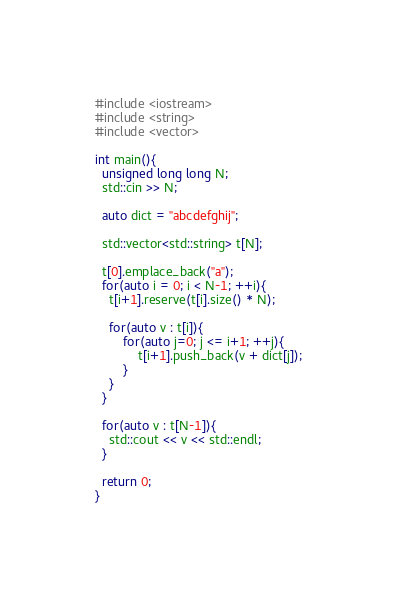<code> <loc_0><loc_0><loc_500><loc_500><_C++_>#include <iostream>
#include <string>
#include <vector>
 
int main(){
  unsigned long long N;
  std::cin >> N;

  auto dict = "abcdefghij";
  
  std::vector<std::string> t[N];

  t[0].emplace_back("a");
  for(auto i = 0; i < N-1; ++i){
    t[i+1].reserve(t[i].size() * N);
    
    for(auto v : t[i]){
      	for(auto j=0; j <= i+1; ++j){
     		t[i+1].push_back(v + dict[j]);
        }
    }
  }
  
  for(auto v : t[N-1]){
   	std::cout << v << std::endl; 
  }
	  
  return 0;
}</code> 